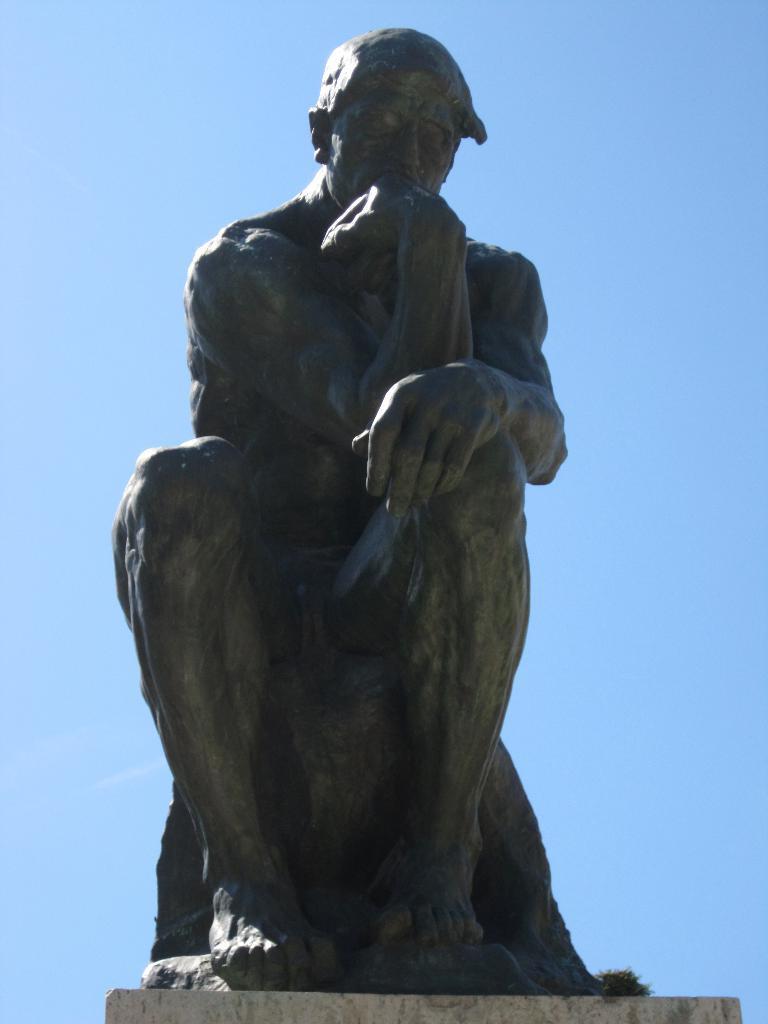Can you describe this image briefly? In this image we can see a statue of a person placed on the ground. In the background we can see the sky. 